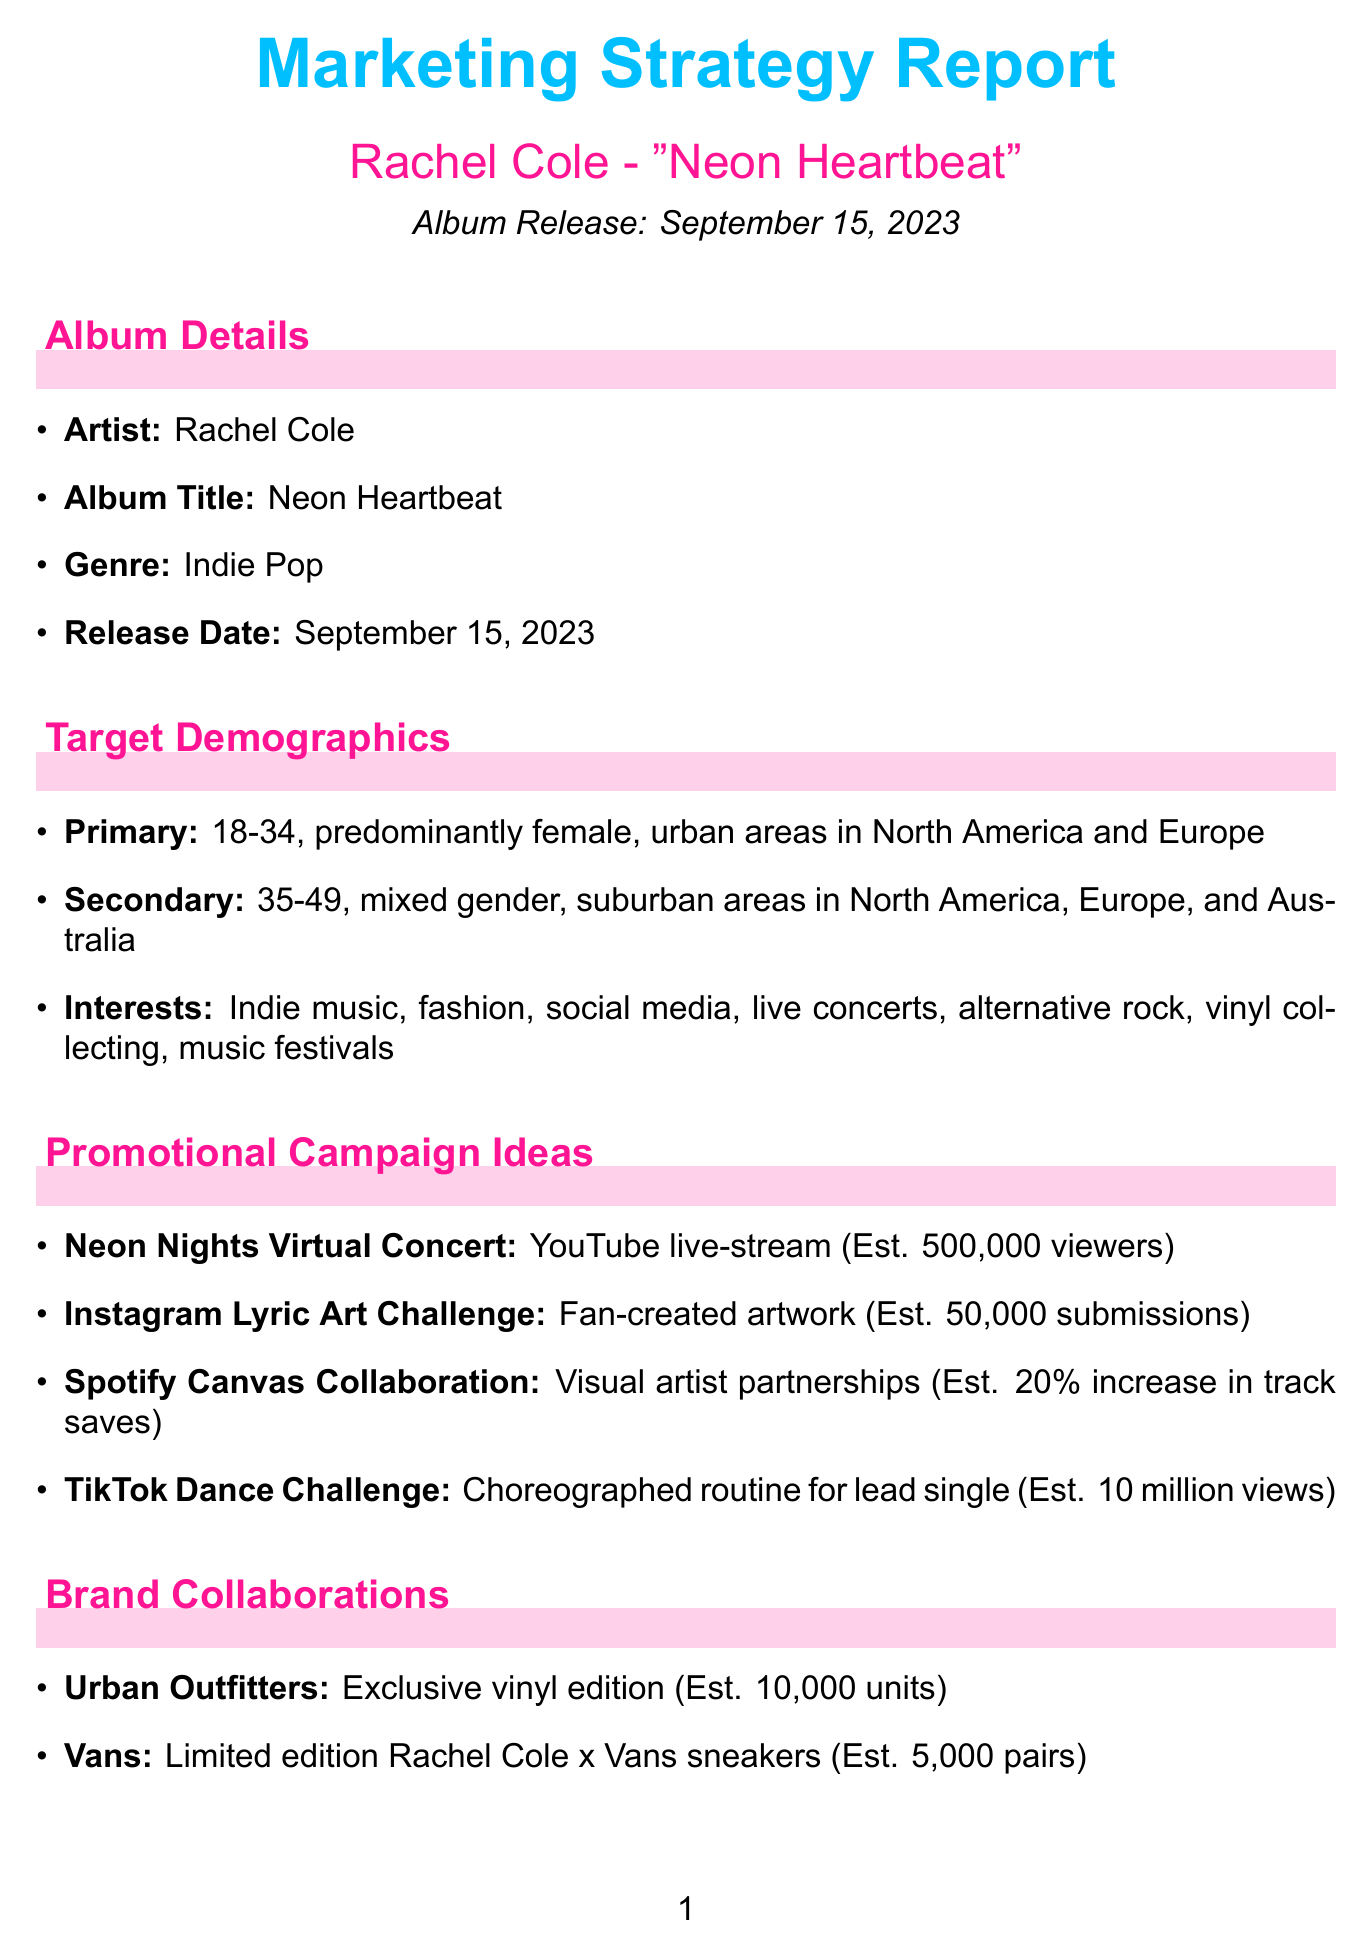What is the release date of the album? The release date is specified in the album details section of the document.
Answer: September 15, 2023 Who is the artist of the album? This information is provided in the album details section.
Answer: Rachel Cole What is the genre of "Neon Heartbeat"? The genre of the album is mentioned under album details.
Answer: Indie Pop What percentage of the budget is allocated to digital advertising? The budget allocation section provides the percentage breakdown for each category.
Answer: 40% What is one of the target demographics for the album? The target demographics section describes the specific groups targeted for the marketing strategy.
Answer: 18-34 Name one promotional campaign idea mentioned in the report. The promotional campaign ideas section lists several campaigns aimed at promoting the album.
Answer: Neon Nights Virtual Concert What is the estimated reach of the "Neon Nights Virtual Concert"? The estimated reach is mentioned in the description of the promotional campaign.
Answer: 500,000 viewers What is a key performance indicator listed in the document? The key performance indicators section highlights metrics used to measure success.
Answer: First-week album sales Which media outlet will feature a live session with Rachel Cole? The media outreach section lists different media engagements for the album promotion.
Answer: BBC Radio 1 